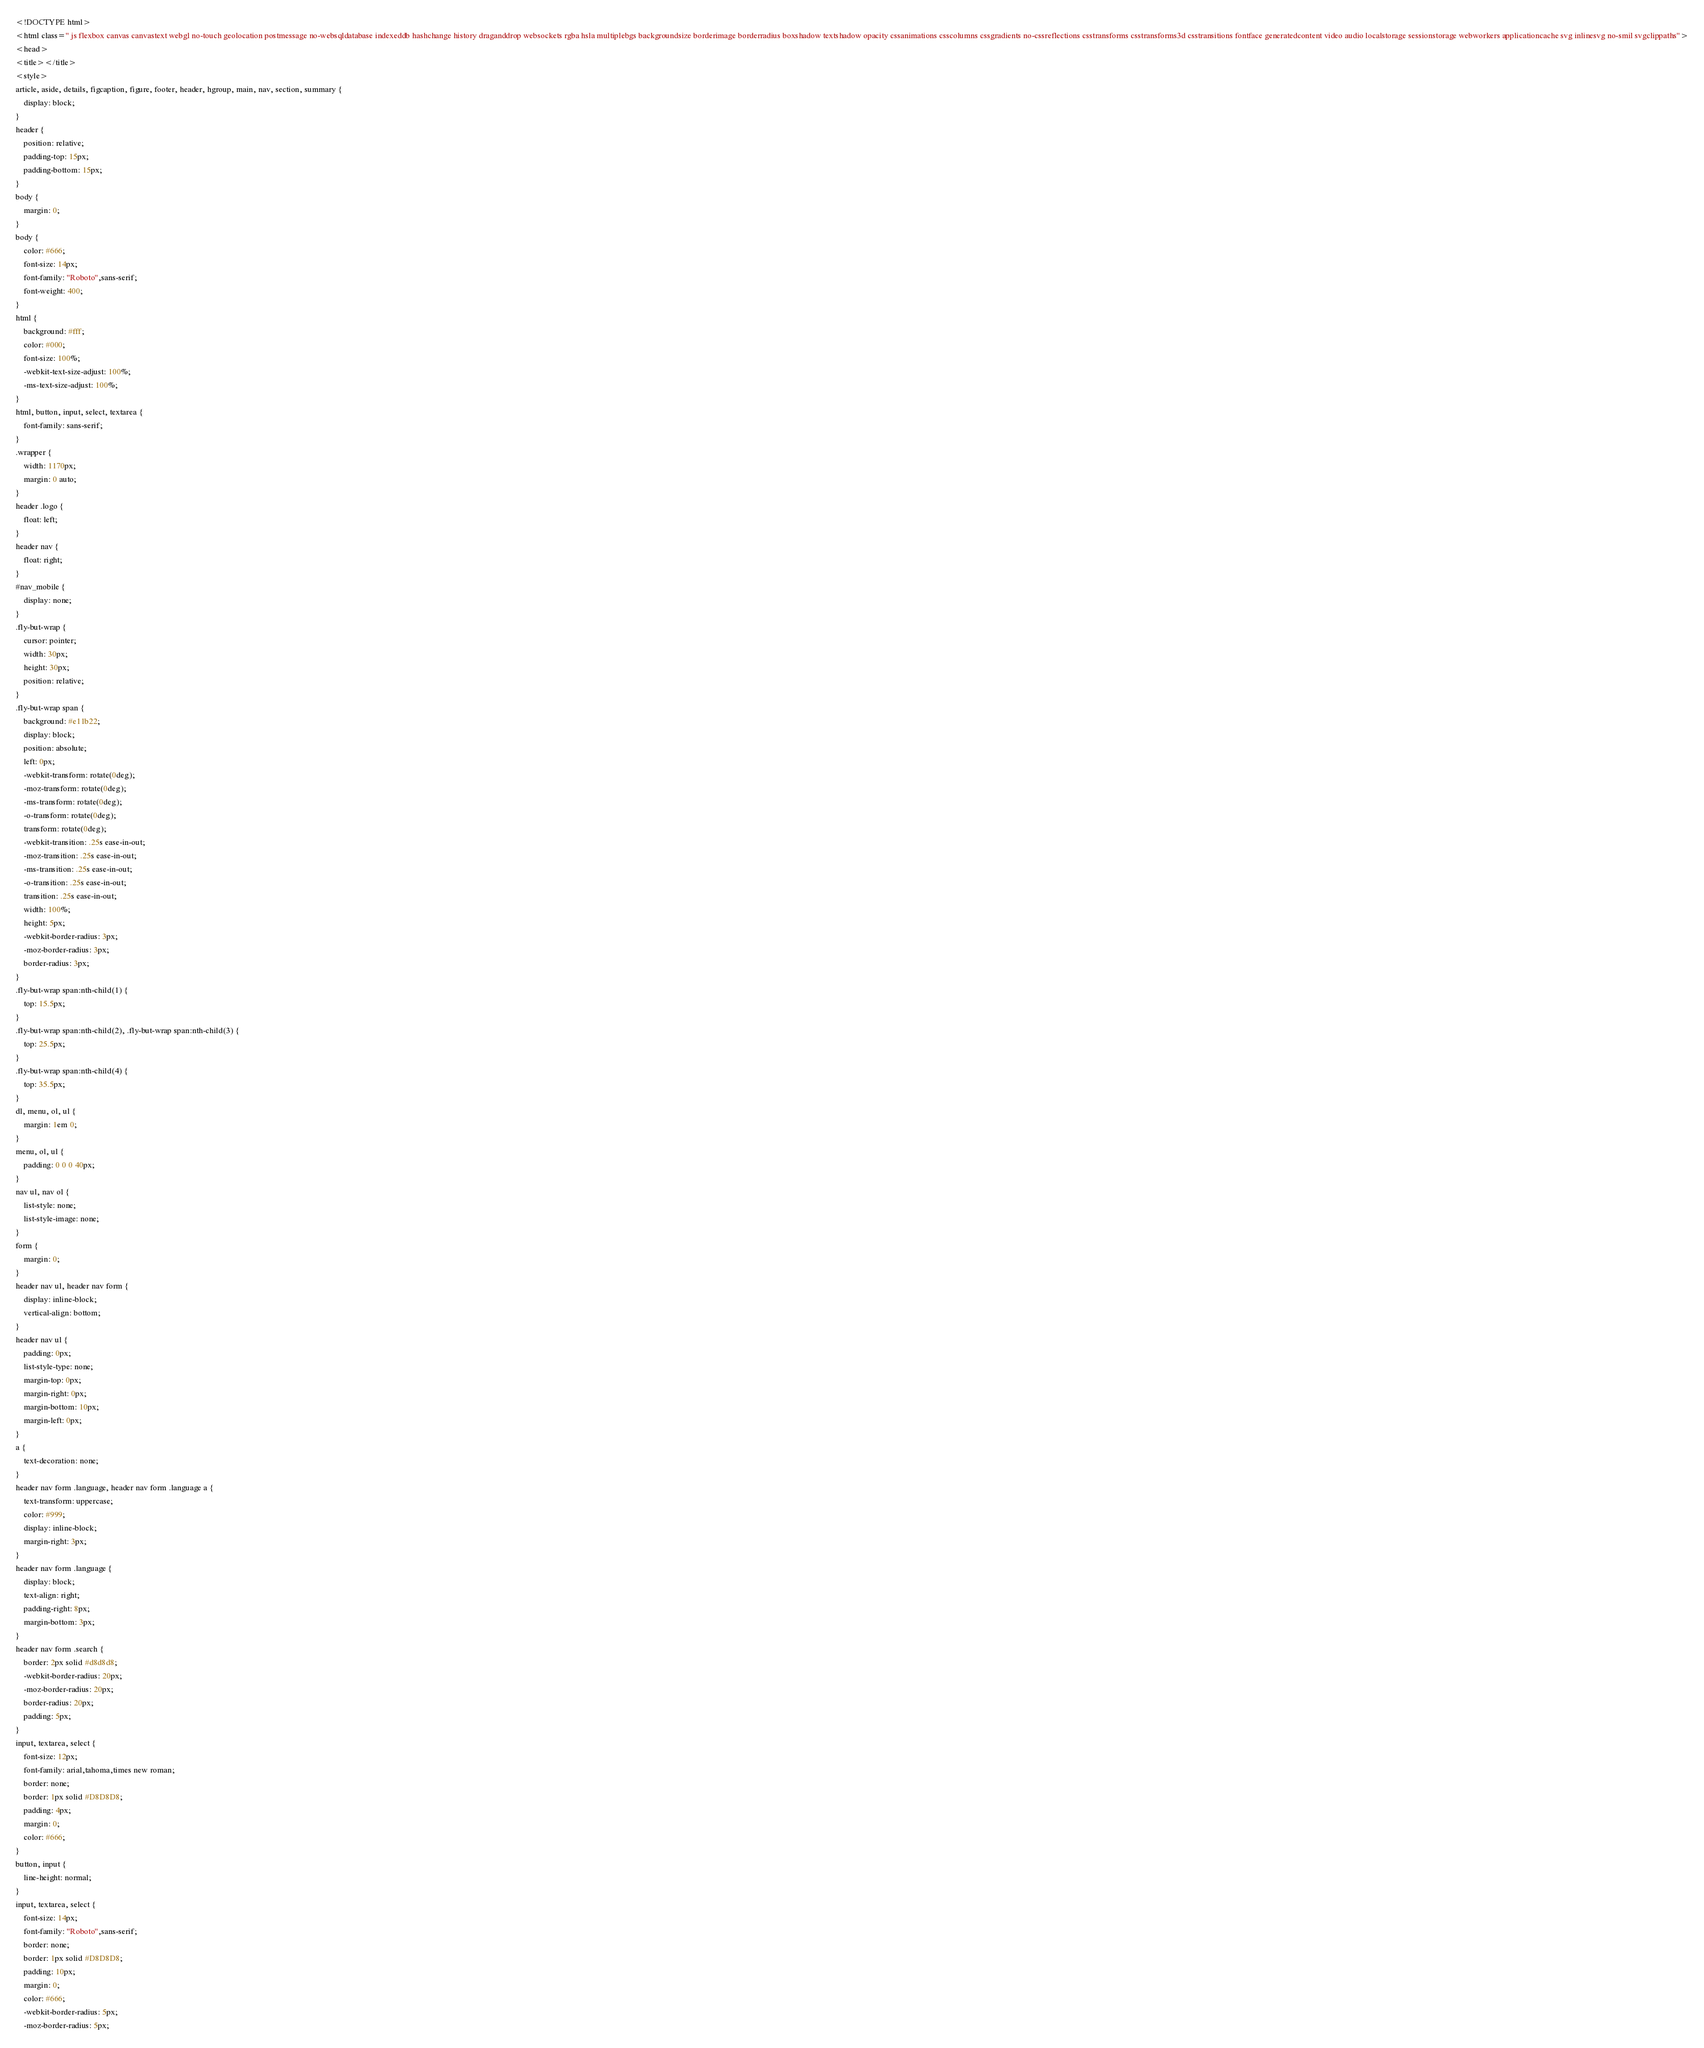<code> <loc_0><loc_0><loc_500><loc_500><_CSS_><!DOCTYPE html>
<html class=" js flexbox canvas canvastext webgl no-touch geolocation postmessage no-websqldatabase indexeddb hashchange history draganddrop websockets rgba hsla multiplebgs backgroundsize borderimage borderradius boxshadow textshadow opacity cssanimations csscolumns cssgradients no-cssreflections csstransforms csstransforms3d csstransitions fontface generatedcontent video audio localstorage sessionstorage webworkers applicationcache svg inlinesvg no-smil svgclippaths">
<head>
<title></title>
<style>
article, aside, details, figcaption, figure, footer, header, hgroup, main, nav, section, summary {
	display: block;
}
header {
	position: relative;
	padding-top: 15px;
	padding-bottom: 15px;
}
body {
	margin: 0;
}
body {
	color: #666;
	font-size: 14px;
	font-family: "Roboto",sans-serif;
	font-weight: 400;
}
html {
	background: #fff;
	color: #000;
	font-size: 100%;
	-webkit-text-size-adjust: 100%;
	-ms-text-size-adjust: 100%;
}
html, button, input, select, textarea {
	font-family: sans-serif;
}
.wrapper {
	width: 1170px;
	margin: 0 auto;
}
header .logo {
	float: left;
}
header nav {
	float: right;
}
#nav_mobile {
	display: none;
}
.fly-but-wrap {
	cursor: pointer;
	width: 30px;
	height: 30px;
	position: relative;
}
.fly-but-wrap span {
	background: #e11b22;
	display: block;
	position: absolute;
	left: 0px;
	-webkit-transform: rotate(0deg);
	-moz-transform: rotate(0deg);
	-ms-transform: rotate(0deg);
	-o-transform: rotate(0deg);
	transform: rotate(0deg);
	-webkit-transition: .25s ease-in-out;
	-moz-transition: .25s ease-in-out;
	-ms-transition: .25s ease-in-out;
	-o-transition: .25s ease-in-out;
	transition: .25s ease-in-out;
	width: 100%;
	height: 5px;
	-webkit-border-radius: 3px;
	-moz-border-radius: 3px;
	border-radius: 3px;
}
.fly-but-wrap span:nth-child(1) {
	top: 15.5px;
}
.fly-but-wrap span:nth-child(2), .fly-but-wrap span:nth-child(3) {
	top: 25.5px;
}
.fly-but-wrap span:nth-child(4) {
	top: 35.5px;
}
dl, menu, ol, ul {
	margin: 1em 0;
}
menu, ol, ul {
	padding: 0 0 0 40px;
}
nav ul, nav ol {
	list-style: none;
	list-style-image: none;
}
form {
	margin: 0;
}
header nav ul, header nav form {
	display: inline-block;
	vertical-align: bottom;
}
header nav ul {
	padding: 0px;
	list-style-type: none;
	margin-top: 0px;
	margin-right: 0px;
	margin-bottom: 10px;
	margin-left: 0px;
}
a {
	text-decoration: none;
}
header nav form .language, header nav form .language a {
	text-transform: uppercase;
	color: #999;
	display: inline-block;
	margin-right: 3px;
}
header nav form .language {
	display: block;
	text-align: right;
	padding-right: 8px;
	margin-bottom: 3px;
}
header nav form .search {
	border: 2px solid #d8d8d8;
	-webkit-border-radius: 20px;
	-moz-border-radius: 20px;
	border-radius: 20px;
	padding: 5px;
}
input, textarea, select {
	font-size: 12px;
	font-family: arial,tahoma,times new roman;
	border: none;
	border: 1px solid #D8D8D8;
	padding: 4px;
	margin: 0;
	color: #666;
}
button, input {
	line-height: normal;
}
input, textarea, select {
	font-size: 14px;
	font-family: "Roboto",sans-serif;
	border: none;
	border: 1px solid #D8D8D8;
	padding: 10px;
	margin: 0;
	color: #666;
	-webkit-border-radius: 5px;
	-moz-border-radius: 5px;</code> 